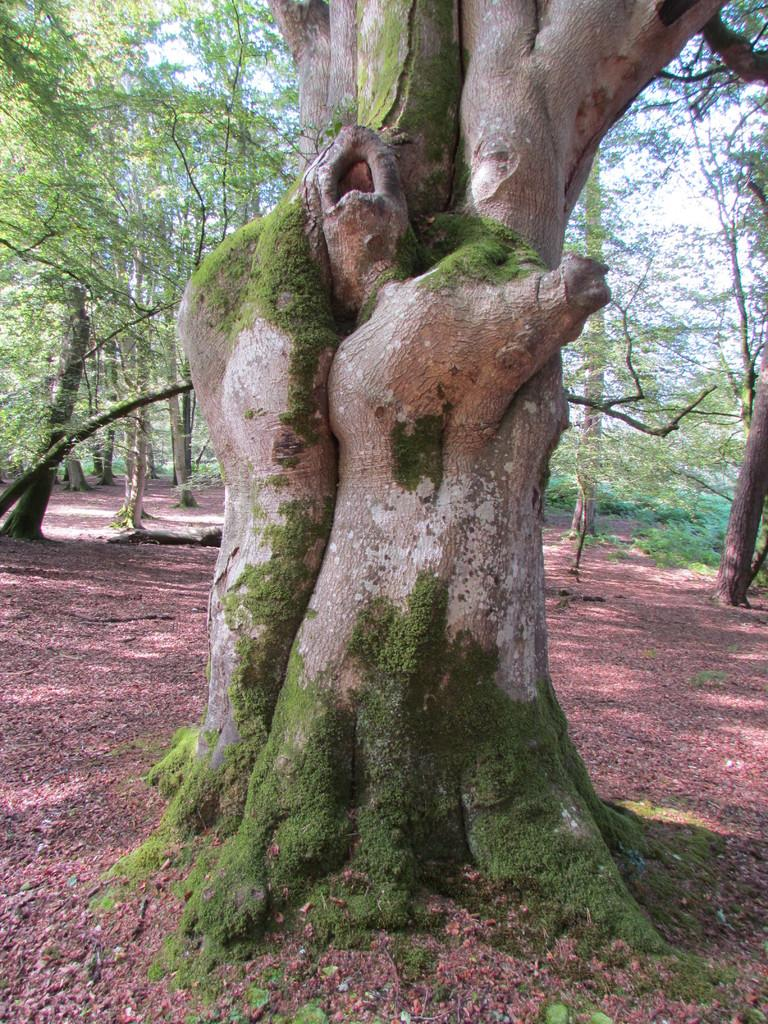What type of vegetation is present in the image? There are many trees in the image. What part of the natural environment is visible at the bottom of the image? The ground is visible at the bottom of the image. What type of landscape does the image depict? The image appears to depict a forest. What type of eggs can be seen in the image? There are no eggs present in the image; it depicts a forest with many trees. What thrilling activity is taking place in the image? There is no thrilling activity depicted in the image; it is a static representation of a forest. 